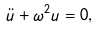<formula> <loc_0><loc_0><loc_500><loc_500>\ddot { u } + \omega ^ { 2 } u = 0 ,</formula> 